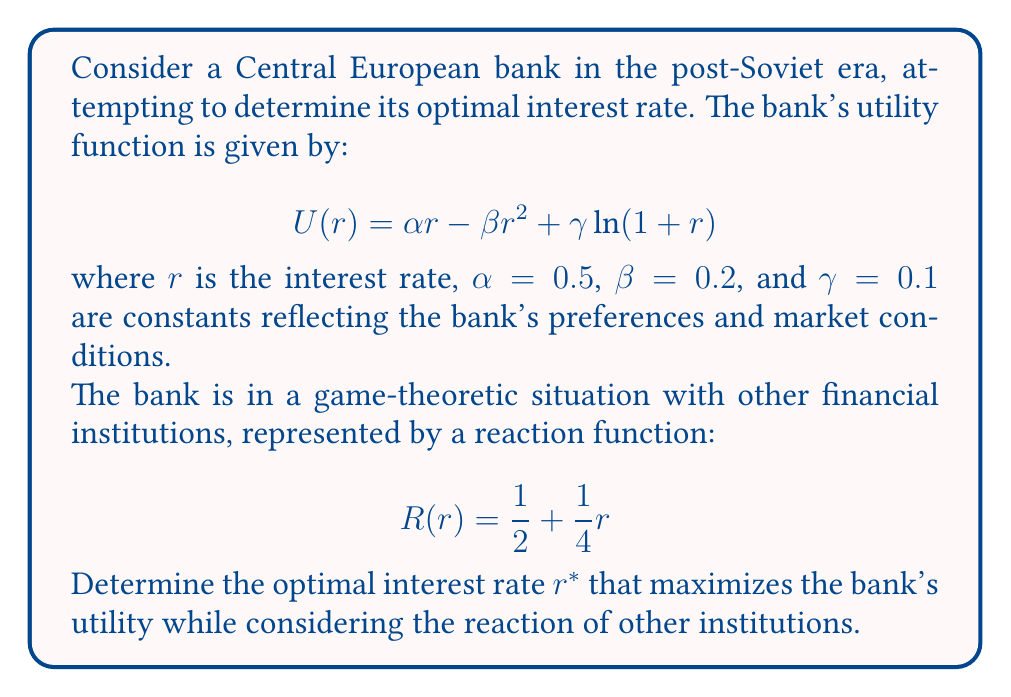Help me with this question. To solve this problem, we'll follow these steps:

1) First, we need to find the bank's best response function by maximizing its utility function:

   $$\frac{dU}{dr} = \alpha - 2\beta r + \frac{\gamma}{1+r} = 0$$

2) Substituting the given values:

   $$0.5 - 0.4r + \frac{0.1}{1+r} = 0$$

3) This equation doesn't have a simple analytical solution, so we'll treat it as the bank's implicit best response function.

4) Next, we need to find the Nash equilibrium, which occurs when the bank's interest rate matches the reaction of other institutions:

   $$r = \frac{1}{2} + \frac{1}{4}r$$

5) Solving this equation:

   $$r = \frac{2}{3}$$

6) Now, we have a system of two equations:

   $$0.5 - 0.4r + \frac{0.1}{1+r} = 0$$
   $$r = \frac{2}{3}$$

7) Substituting the second equation into the first:

   $$0.5 - 0.4(\frac{2}{3}) + \frac{0.1}{1+\frac{2}{3}} = 0$$

8) Simplifying:

   $$0.5 - \frac{4}{15} + \frac{3}{50} = 0$$

9) This equation is satisfied, confirming that $r^* = \frac{2}{3}$ is indeed the optimal interest rate.
Answer: $r^* = \frac{2}{3}$ 